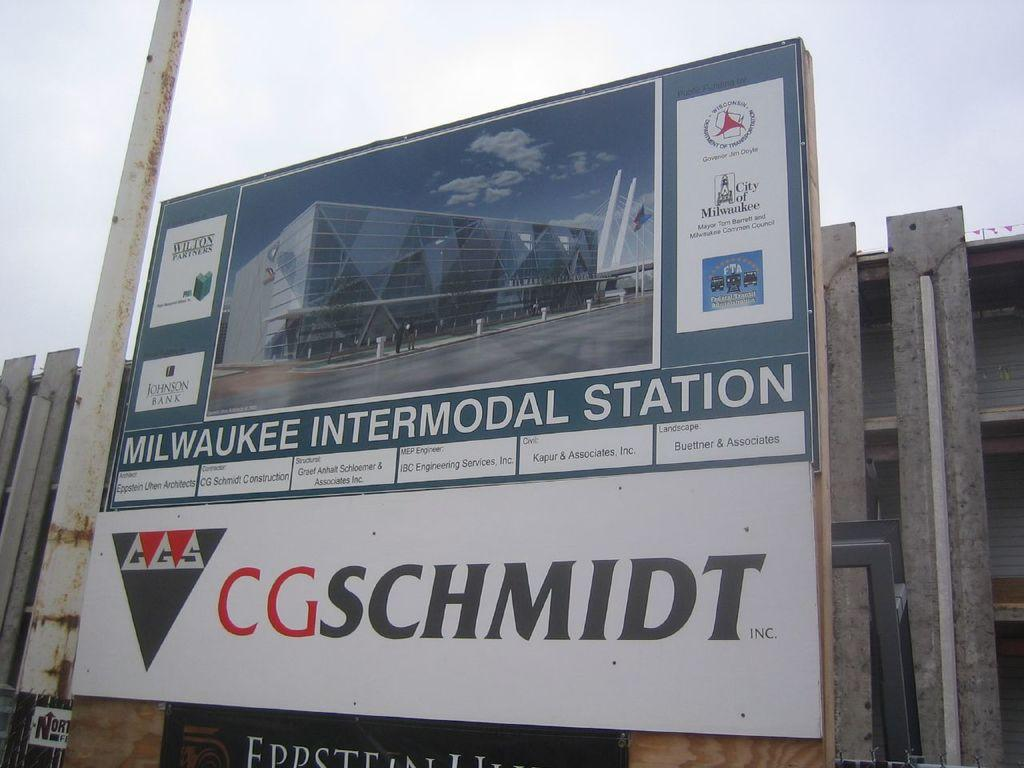<image>
Summarize the visual content of the image. CG Schmidt is building the Milwaukee Intermodal Station. 